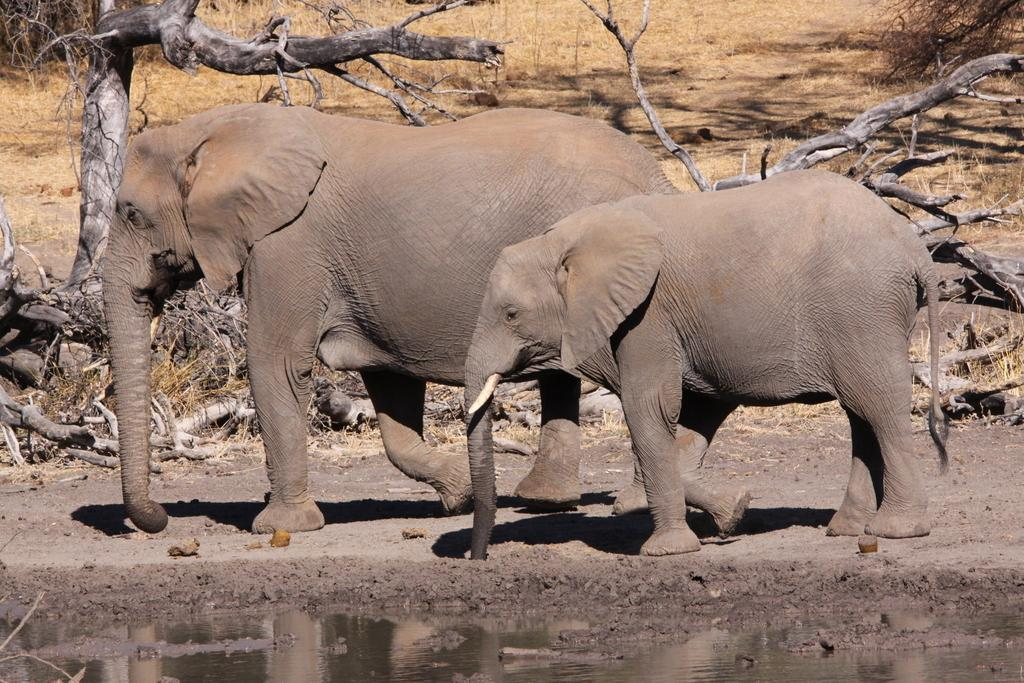How many elephants are in the image? There are two elephants in the image. What are the elephants doing in the image? The elephants are walking on the ground in the image. What can be seen in the background of the image? There is a tree and woods visible in the background of the image. What type of terrain is present in the image? Grass is present at the top of the image, and water is visible at the bottom of the image. What type of drum can be seen in the hands of the elephants in the image? There is no drum present in the image; the elephants are simply walking on the ground. Can you tell me what the elephants are writing in their notebooks in the image? There are no notebooks present in the image; the elephants are not engaged in any writing activity. 